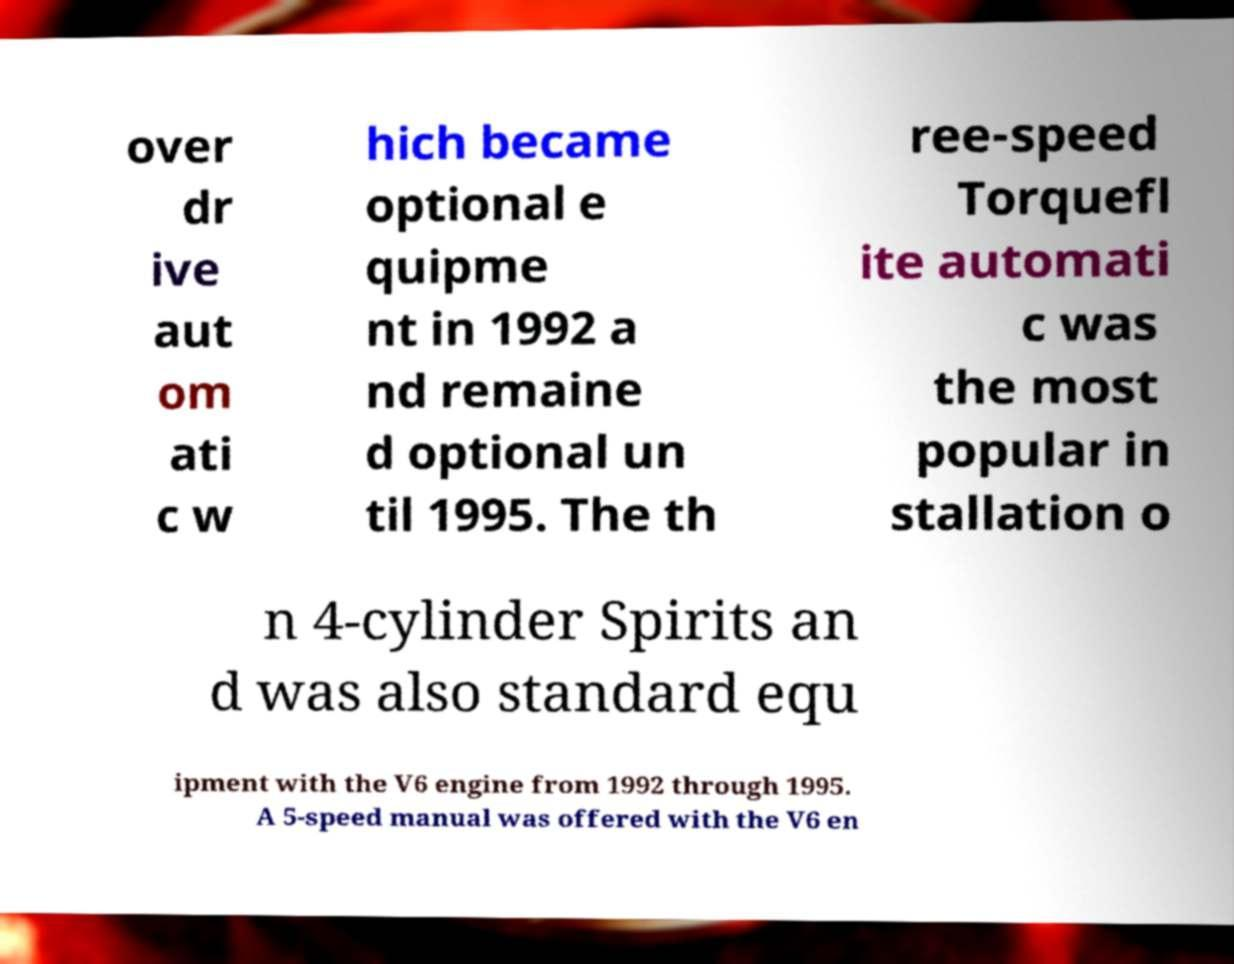What messages or text are displayed in this image? I need them in a readable, typed format. over dr ive aut om ati c w hich became optional e quipme nt in 1992 a nd remaine d optional un til 1995. The th ree-speed Torquefl ite automati c was the most popular in stallation o n 4-cylinder Spirits an d was also standard equ ipment with the V6 engine from 1992 through 1995. A 5-speed manual was offered with the V6 en 